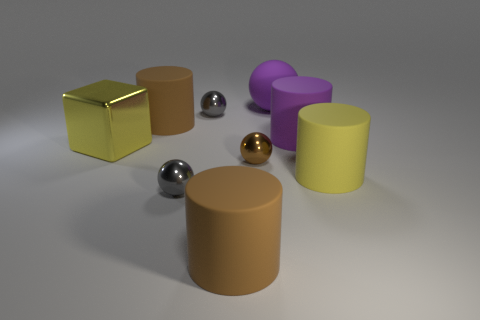Subtract 2 cylinders. How many cylinders are left? 2 Subtract all brown spheres. How many spheres are left? 3 Subtract all brown balls. How many balls are left? 3 Add 1 tiny gray shiny objects. How many objects exist? 10 Subtract all purple cylinders. Subtract all yellow cubes. How many cylinders are left? 3 Subtract all cylinders. How many objects are left? 5 Subtract all brown balls. Subtract all yellow metal things. How many objects are left? 7 Add 4 big purple rubber cylinders. How many big purple rubber cylinders are left? 5 Add 1 small purple spheres. How many small purple spheres exist? 1 Subtract 1 yellow cylinders. How many objects are left? 8 